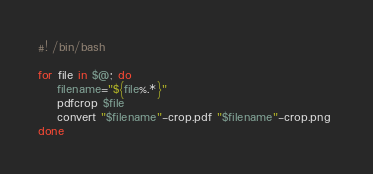<code> <loc_0><loc_0><loc_500><loc_500><_Bash_>#! /bin/bash

for file in $@; do
    filename="${file%.*}"
    pdfcrop $file
    convert "$filename"-crop.pdf "$filename"-crop.png 
done
</code> 